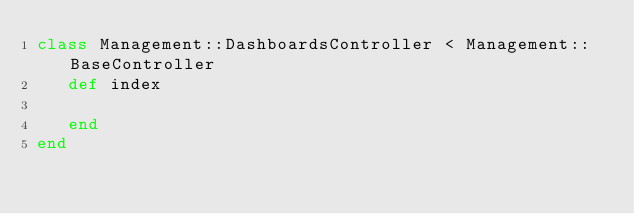Convert code to text. <code><loc_0><loc_0><loc_500><loc_500><_Ruby_>class Management::DashboardsController < Management::BaseController
   def index

   end
end
</code> 